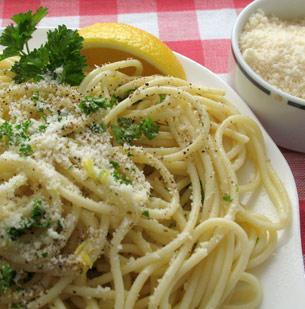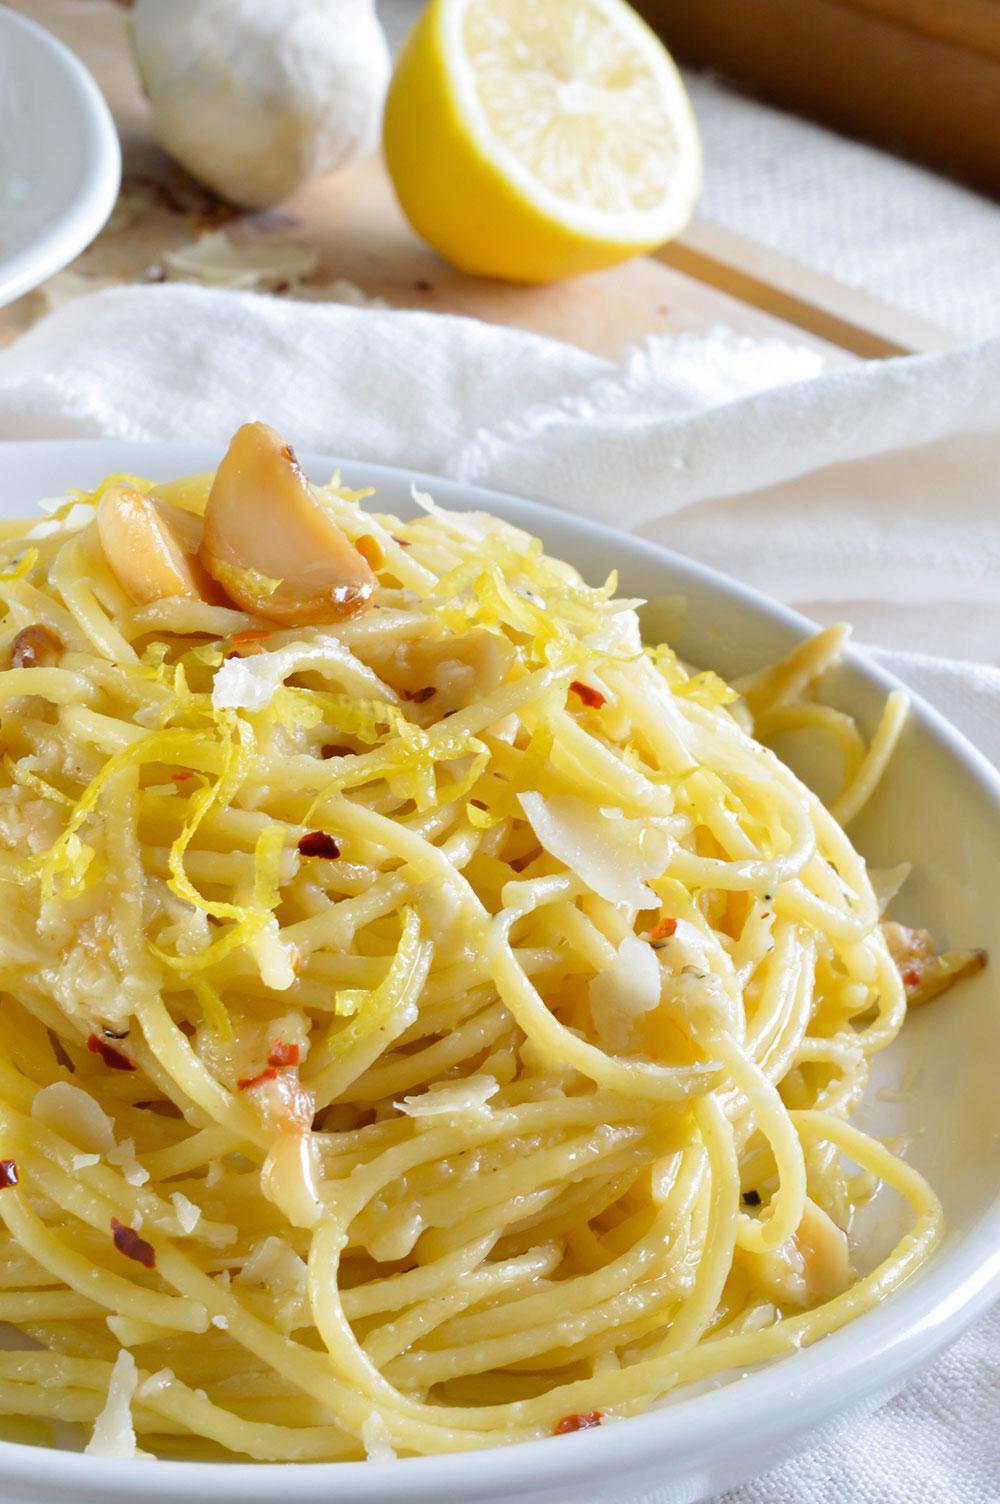The first image is the image on the left, the second image is the image on the right. Evaluate the accuracy of this statement regarding the images: "An image shows a slice of citrus fruit garnishing a white bowl of noodles on a checkered cloth.". Is it true? Answer yes or no. Yes. The first image is the image on the left, the second image is the image on the right. Evaluate the accuracy of this statement regarding the images: "A single wedge of lemon sits on top of a meatless noodle dish in the image on the left.". Is it true? Answer yes or no. Yes. 